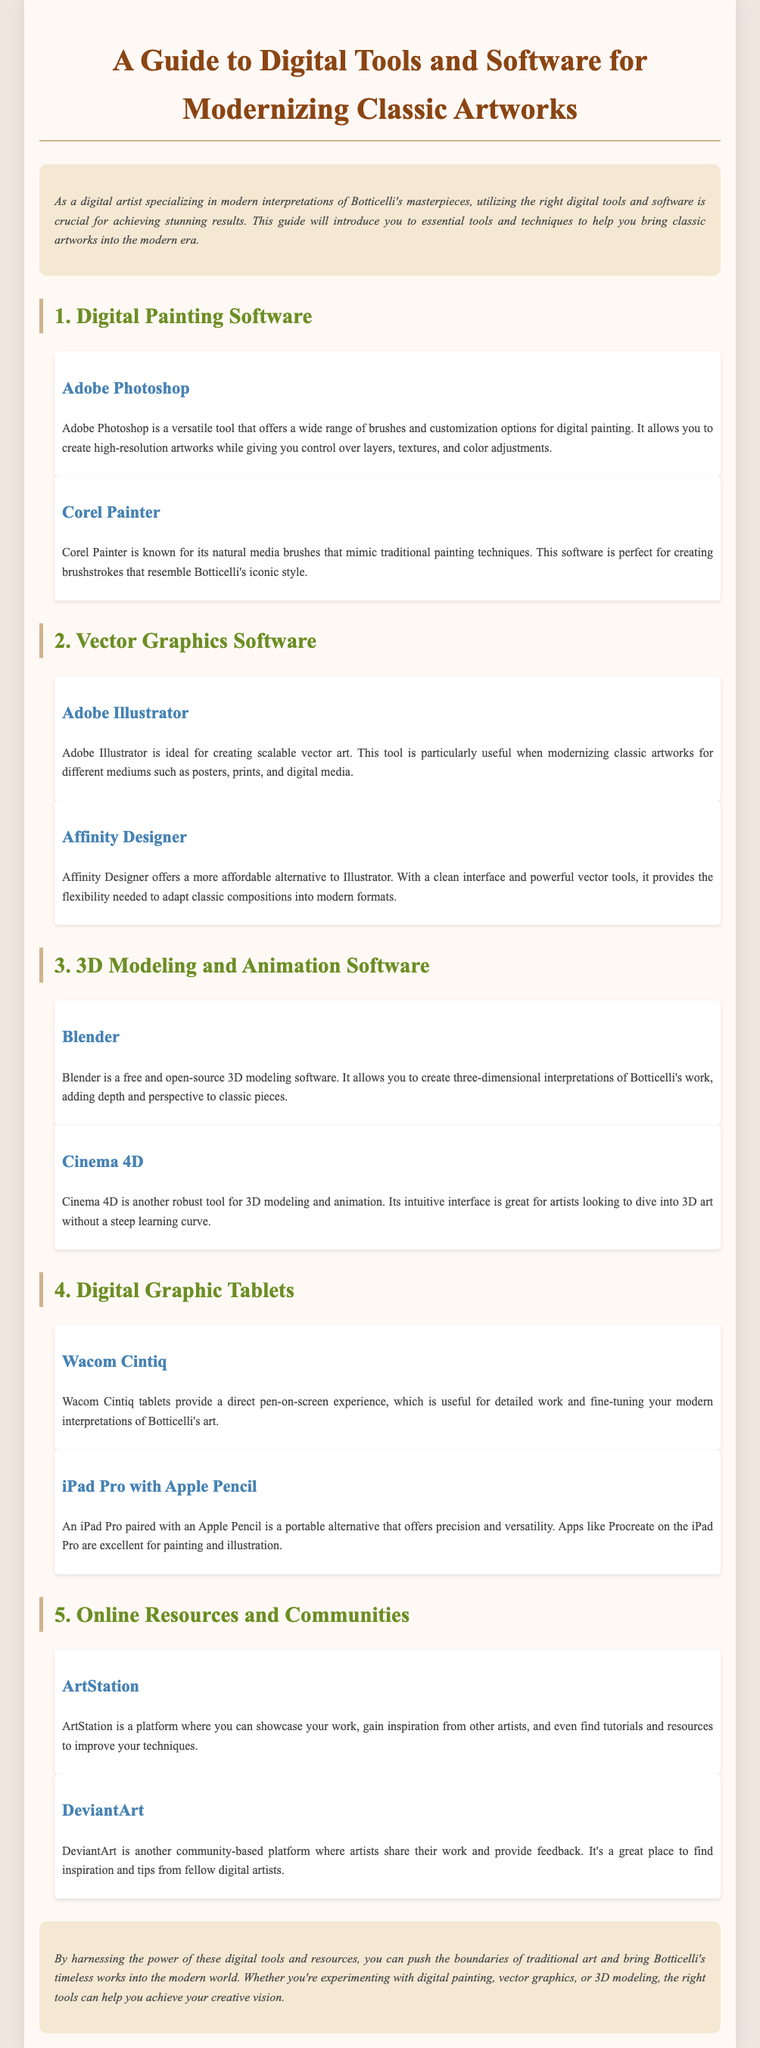What is the title of the guide? The title of the guide is prominently displayed at the top of the document.
Answer: A Guide to Digital Tools and Software for Modernizing Classic Artworks Which software is known for its natural media brushes? This information can be found in the section about Digital Painting Software, specifically under Corel Painter.
Answer: Corel Painter What digital graphic tablet provides a pen-on-screen experience? The document specifically mentions this feature in the section about Digital Graphic Tablets.
Answer: Wacom Cintiq How many main sections are in the guide? The sections are numbered, and counting them provides the total.
Answer: Five What website is mentioned for showcasing work and finding tutorials? This can be found in the section about Online Resources and Communities, specifically under ArtStation.
Answer: ArtStation Which software is described as a robust tool for 3D modeling and animation? The section on 3D Modeling and Animation Software lists this tool explicitly.
Answer: Cinema 4D What is the alternative to Adobe Illustrator mentioned in the document? This information is provided in the section about Vector Graphics Software.
Answer: Affinity Designer Which tablet is described as a portable alternative with precision? This detail is included in the subsection about digital graphic tablets.
Answer: iPad Pro with Apple Pencil 